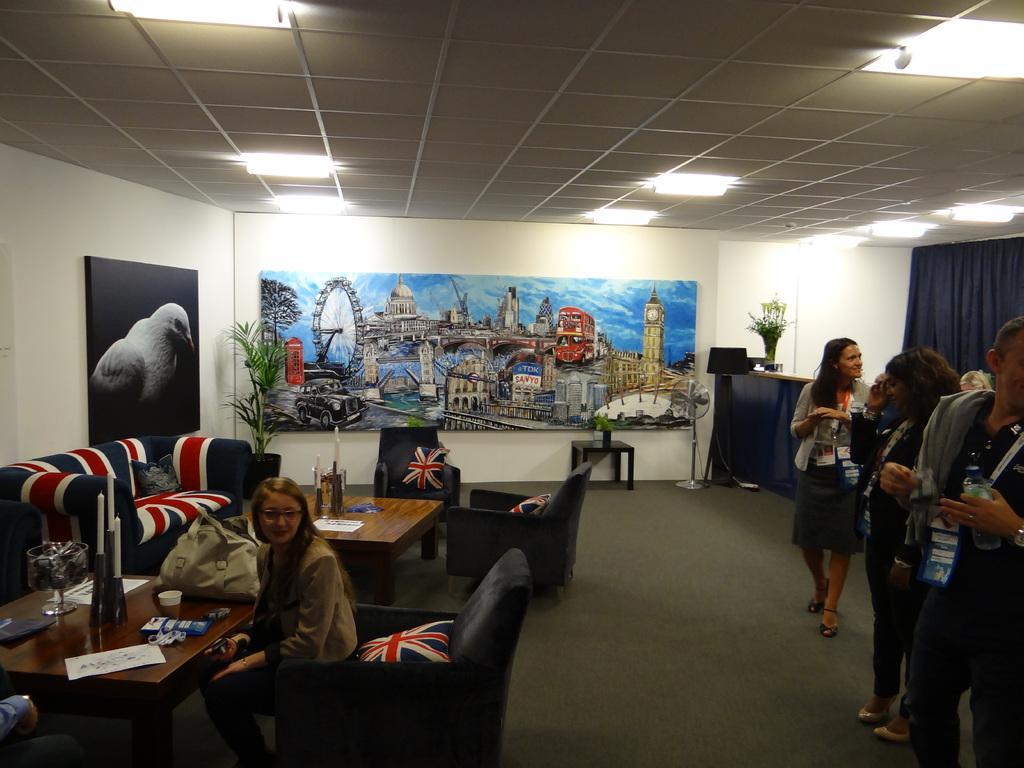How would you summarize this image in a sentence or two? in the picture we can see a woman sitting on the sofa with the table in front of it ,we can also see another woman walking,we can see some of the persons standing,we can also see a beautiful scenery on the wall,we can see a plant ,we can also see the table and table fan , we can also see lights in the roof. 